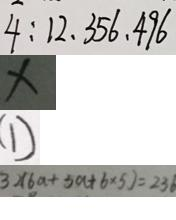Convert formula to latex. <formula><loc_0><loc_0><loc_500><loc_500>4 : 1 2 、 3 5 6 、 4 9 6 
 \times 
 ( 1 ) 
 3 \times ( 6 a + 5 a + 6 \times 5 ) = 2 3 6</formula> 